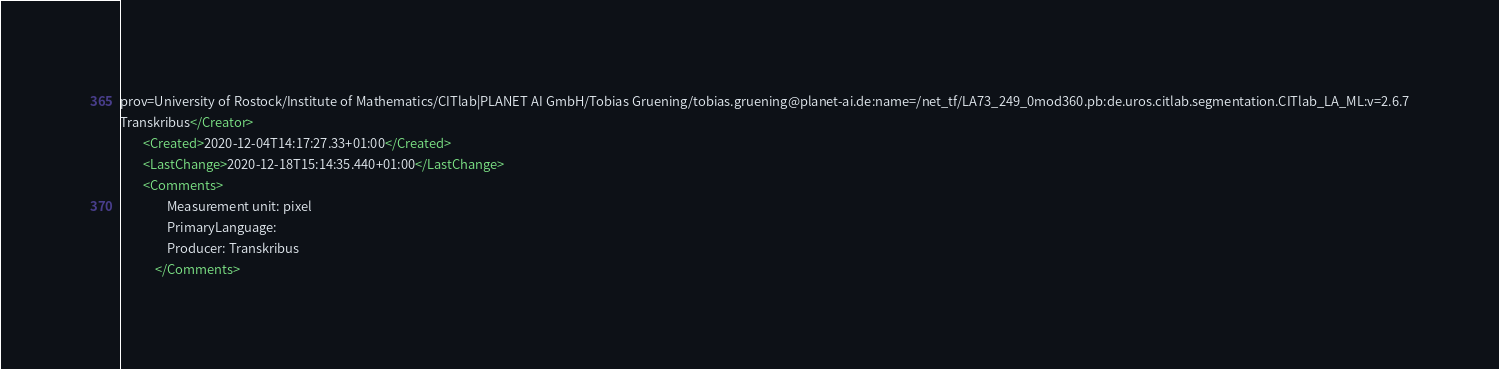<code> <loc_0><loc_0><loc_500><loc_500><_XML_>prov=University of Rostock/Institute of Mathematics/CITlab|PLANET AI GmbH/Tobias Gruening/tobias.gruening@planet-ai.de:name=/net_tf/LA73_249_0mod360.pb:de.uros.citlab.segmentation.CITlab_LA_ML:v=2.6.7
Transkribus</Creator>
        <Created>2020-12-04T14:17:27.33+01:00</Created>
        <LastChange>2020-12-18T15:14:35.440+01:00</LastChange>
        <Comments>
                Measurement unit: pixel
                PrimaryLanguage: 
                Producer: Transkribus
            </Comments></code> 